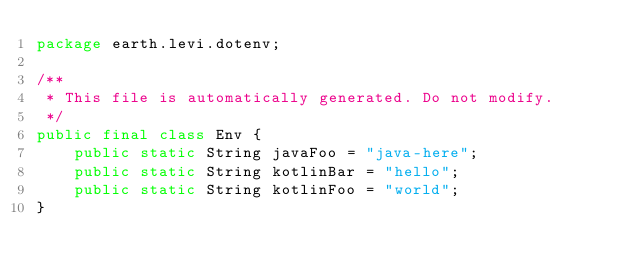Convert code to text. <code><loc_0><loc_0><loc_500><loc_500><_Java_>package earth.levi.dotenv;

/**
 * This file is automatically generated. Do not modify. 
 */
public final class Env {
    public static String javaFoo = "java-here";
    public static String kotlinBar = "hello";
    public static String kotlinFoo = "world";
}
</code> 